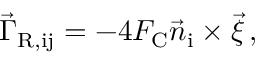<formula> <loc_0><loc_0><loc_500><loc_500>\vec { \Gamma } _ { R , i j } = - 4 F _ { C } \vec { n } _ { i } \times \vec { \xi } \, ,</formula> 